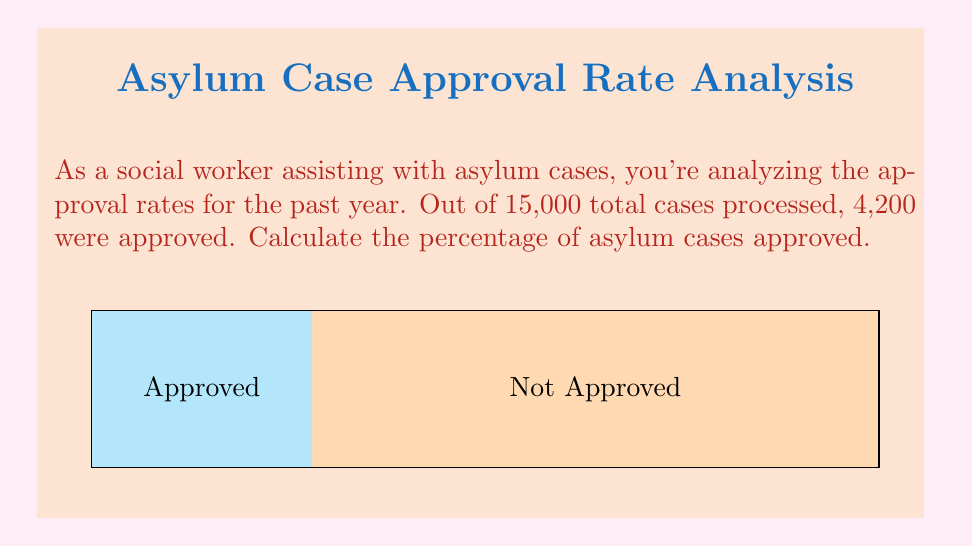Solve this math problem. To calculate the percentage of asylum cases approved, we need to:

1. Identify the total number of cases and the number of approved cases:
   Total cases: 15,000
   Approved cases: 4,200

2. Use the formula for percentage:
   $$ \text{Percentage} = \frac{\text{Part}}{\text{Whole}} \times 100\% $$

3. Plug in the values:
   $$ \text{Percentage approved} = \frac{4,200}{15,000} \times 100\% $$

4. Perform the division:
   $$ \frac{4,200}{15,000} = 0.28 $$

5. Multiply by 100% to get the final percentage:
   $$ 0.28 \times 100\% = 28\% $$

Therefore, the percentage of asylum cases approved is 28%.
Answer: 28% 